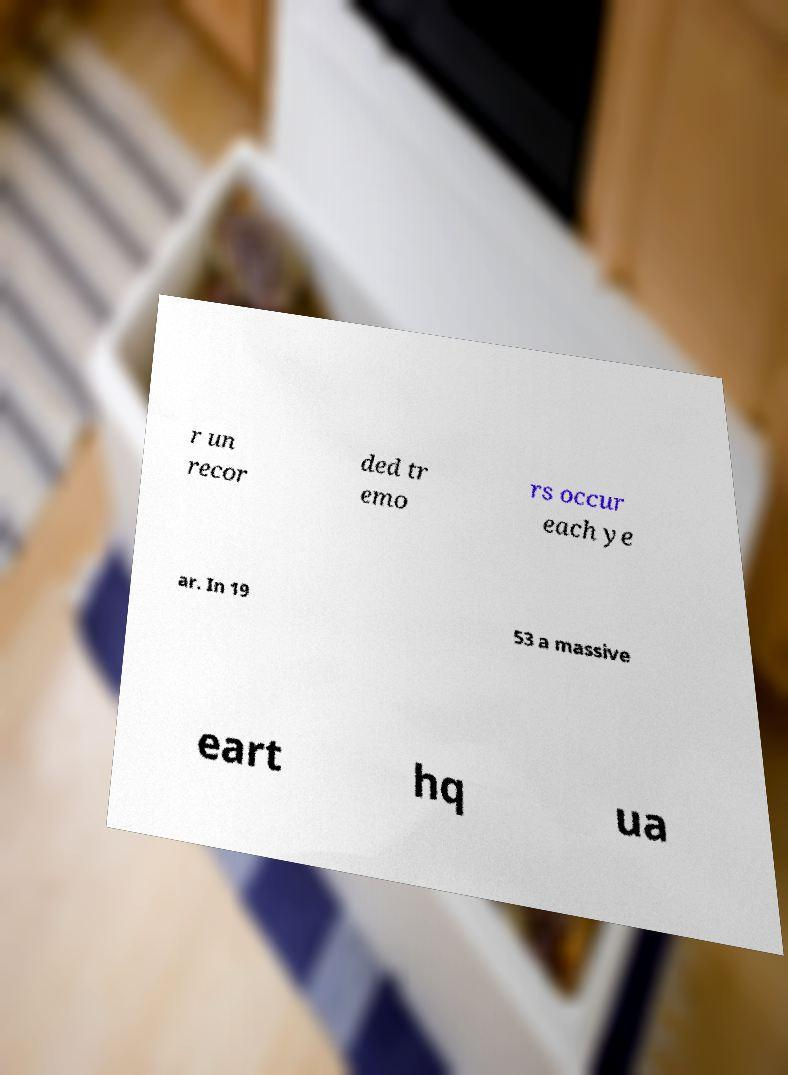There's text embedded in this image that I need extracted. Can you transcribe it verbatim? r un recor ded tr emo rs occur each ye ar. In 19 53 a massive eart hq ua 